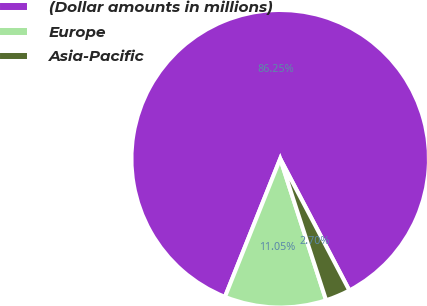Convert chart to OTSL. <chart><loc_0><loc_0><loc_500><loc_500><pie_chart><fcel>(Dollar amounts in millions)<fcel>Europe<fcel>Asia-Pacific<nl><fcel>86.24%<fcel>11.05%<fcel>2.7%<nl></chart> 